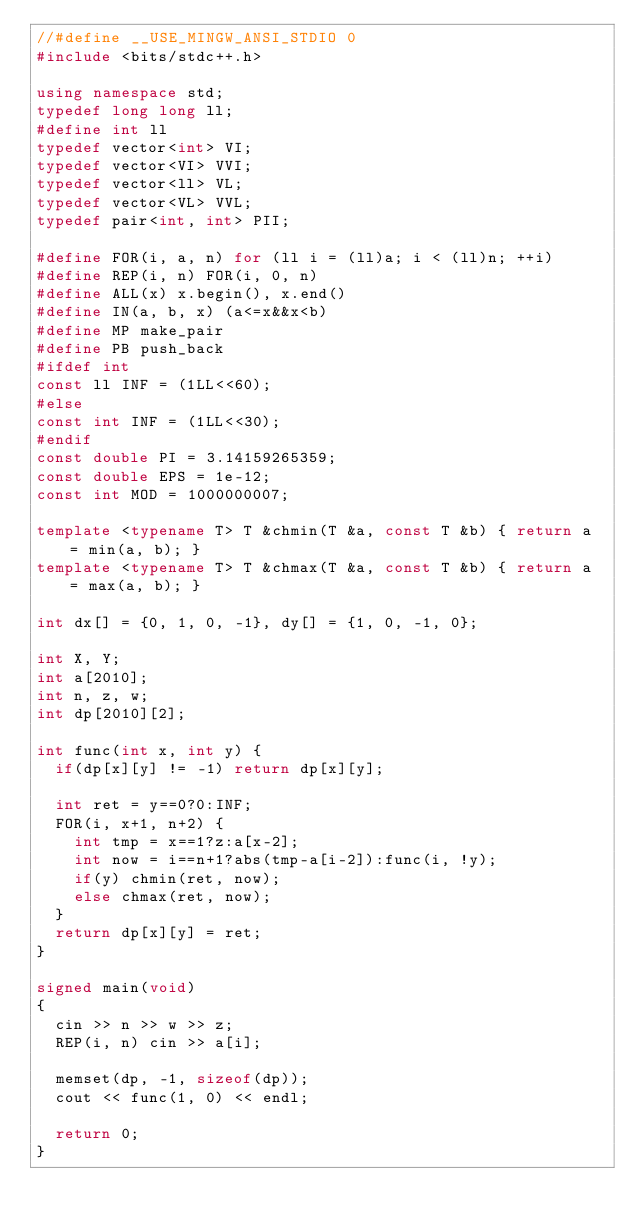<code> <loc_0><loc_0><loc_500><loc_500><_C++_>//#define __USE_MINGW_ANSI_STDIO 0
#include <bits/stdc++.h>

using namespace std;
typedef long long ll;
#define int ll
typedef vector<int> VI;
typedef vector<VI> VVI;
typedef vector<ll> VL;
typedef vector<VL> VVL;
typedef pair<int, int> PII;

#define FOR(i, a, n) for (ll i = (ll)a; i < (ll)n; ++i)
#define REP(i, n) FOR(i, 0, n)
#define ALL(x) x.begin(), x.end()
#define IN(a, b, x) (a<=x&&x<b)
#define MP make_pair
#define PB push_back
#ifdef int
const ll INF = (1LL<<60);
#else
const int INF = (1LL<<30);
#endif
const double PI = 3.14159265359;
const double EPS = 1e-12;
const int MOD = 1000000007;

template <typename T> T &chmin(T &a, const T &b) { return a = min(a, b); }
template <typename T> T &chmax(T &a, const T &b) { return a = max(a, b); }

int dx[] = {0, 1, 0, -1}, dy[] = {1, 0, -1, 0};

int X, Y;
int a[2010];
int n, z, w;
int dp[2010][2];

int func(int x, int y) {
  if(dp[x][y] != -1) return dp[x][y];

  int ret = y==0?0:INF;
  FOR(i, x+1, n+2) {
    int tmp = x==1?z:a[x-2];
    int now = i==n+1?abs(tmp-a[i-2]):func(i, !y);
    if(y) chmin(ret, now);
    else chmax(ret, now);
  }
  return dp[x][y] = ret;
}

signed main(void)
{
  cin >> n >> w >> z;
  REP(i, n) cin >> a[i];

  memset(dp, -1, sizeof(dp));
  cout << func(1, 0) << endl;

  return 0;
}
</code> 